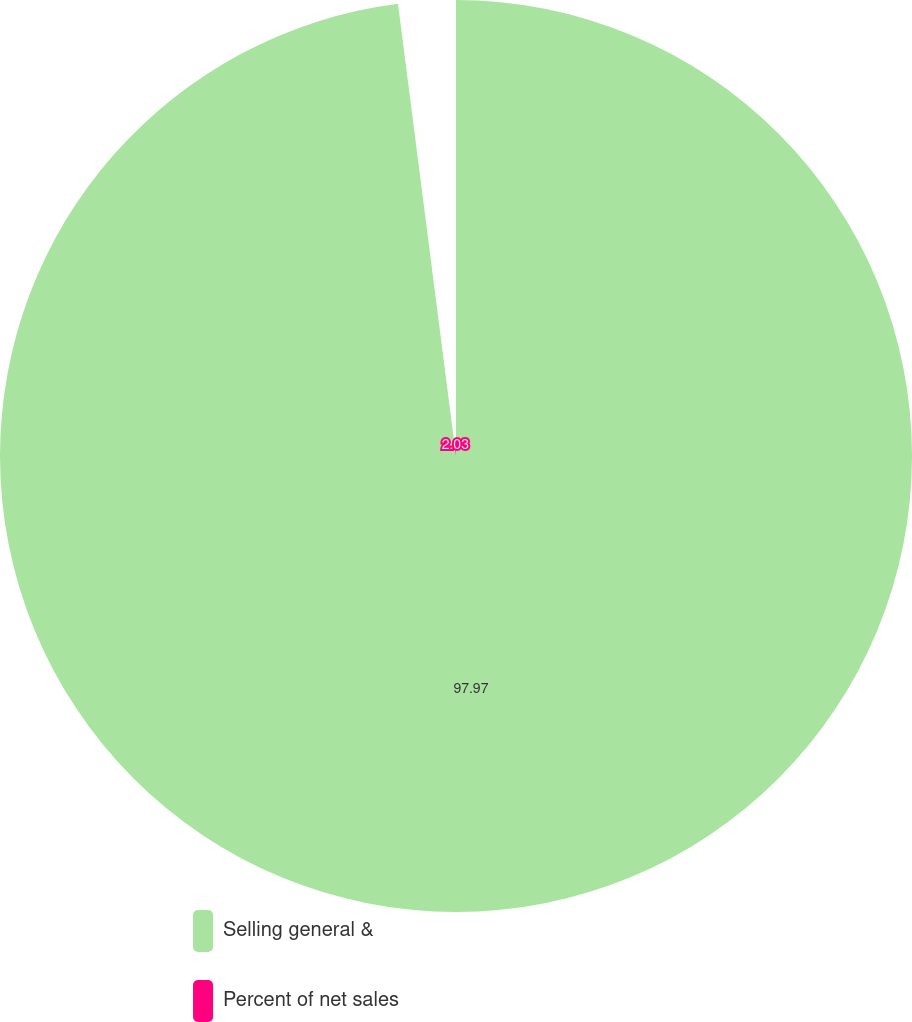Convert chart to OTSL. <chart><loc_0><loc_0><loc_500><loc_500><pie_chart><fcel>Selling general &<fcel>Percent of net sales<nl><fcel>97.97%<fcel>2.03%<nl></chart> 